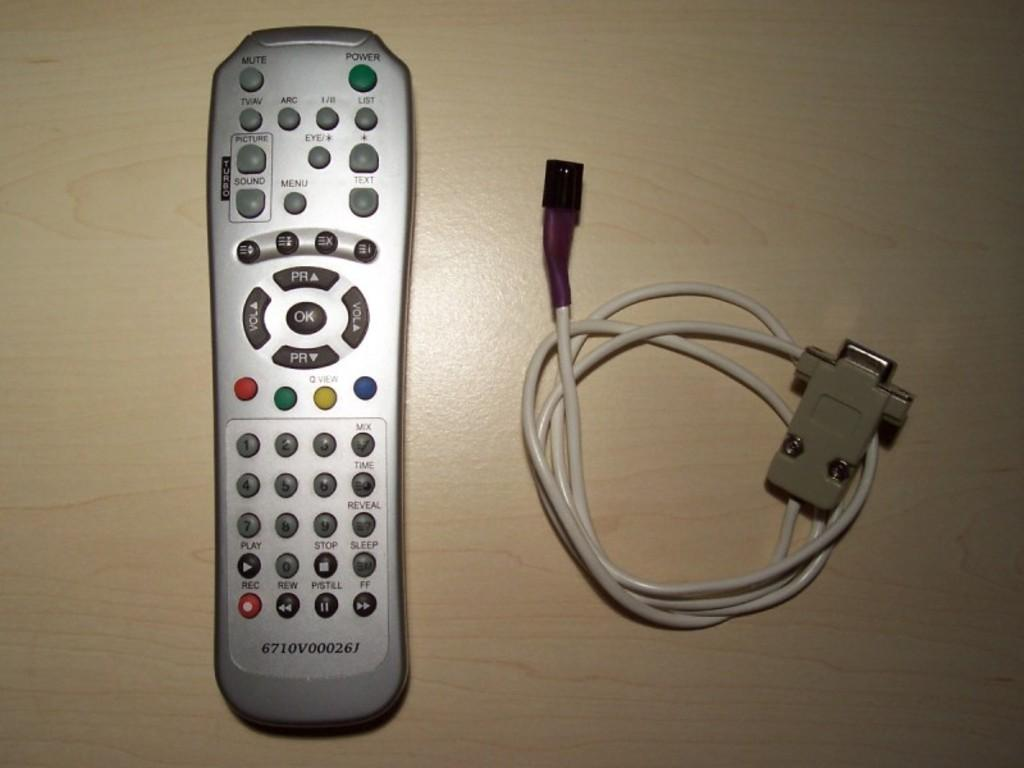<image>
Describe the image concisely. A cable and adapter sits next to a silver remote with number 6710v000261 at the bottom. 